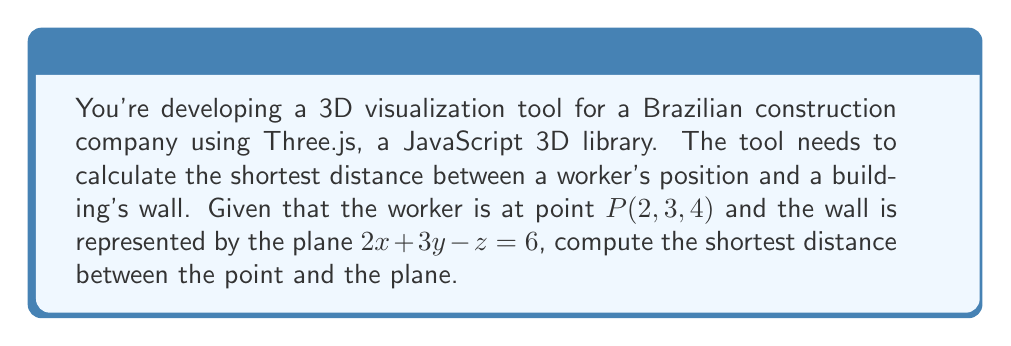What is the answer to this math problem? To find the shortest distance between a point and a plane, we can use the formula:

$$d = \frac{|Ax_0 + By_0 + Cz_0 + D|}{\sqrt{A^2 + B^2 + C^2}}$$

Where $(x_0, y_0, z_0)$ are the coordinates of the point, and $Ax + By + Cz + D = 0$ is the general equation of the plane.

Given:
- Point $P(2, 3, 4)$
- Plane equation: $2x + 3y - z = 6$

Step 1: Identify the coefficients in the plane equation.
$A = 2$, $B = 3$, $C = -1$, $D = -6$ (note that we moved the 6 to the right side of the equation)

Step 2: Substitute the values into the distance formula.
$$d = \frac{|2(2) + 3(3) + (-1)(4) + (-6)|}{\sqrt{2^2 + 3^2 + (-1)^2}}$$

Step 3: Simplify the numerator.
$$d = \frac{|4 + 9 - 4 - 6|}{\sqrt{4 + 9 + 1}}$$
$$d = \frac{|3|}{\sqrt{14}}$$

Step 4: Simplify the fraction.
$$d = \frac{3}{\sqrt{14}}$$

Step 5: Optionally, rationalize the denominator.
$$d = \frac{3}{\sqrt{14}} \cdot \frac{\sqrt{14}}{\sqrt{14}} = \frac{3\sqrt{14}}{14}$$

Both forms are correct, but in programming, you might prefer to keep it as $\frac{3}{\sqrt{14}}$ for easier computation.
Answer: The shortest distance between the point $P(2, 3, 4)$ and the plane $2x + 3y - z = 6$ is $\frac{3}{\sqrt{14}}$ or $\frac{3\sqrt{14}}{14}$ units. 